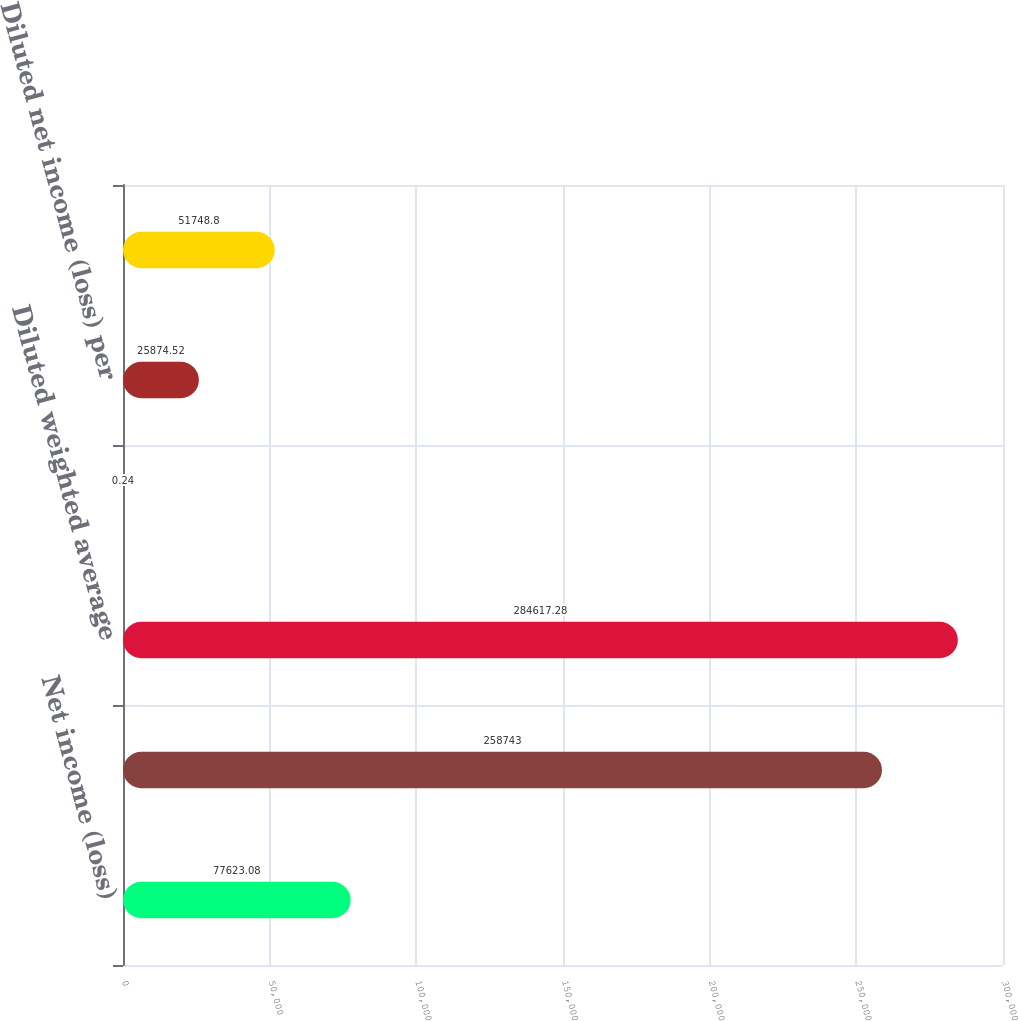Convert chart to OTSL. <chart><loc_0><loc_0><loc_500><loc_500><bar_chart><fcel>Net income (loss)<fcel>Basic weighted average common<fcel>Diluted weighted average<fcel>Basic net income (loss) per<fcel>Diluted net income (loss) per<fcel>Outstanding stock options<nl><fcel>77623.1<fcel>258743<fcel>284617<fcel>0.24<fcel>25874.5<fcel>51748.8<nl></chart> 